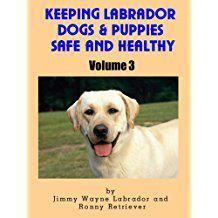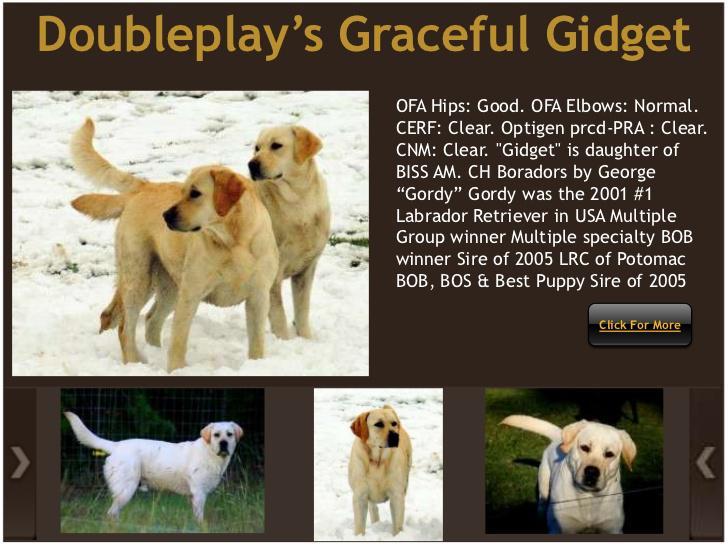The first image is the image on the left, the second image is the image on the right. Considering the images on both sides, is "One dog in the left image has its tongue out." valid? Answer yes or no. Yes. 